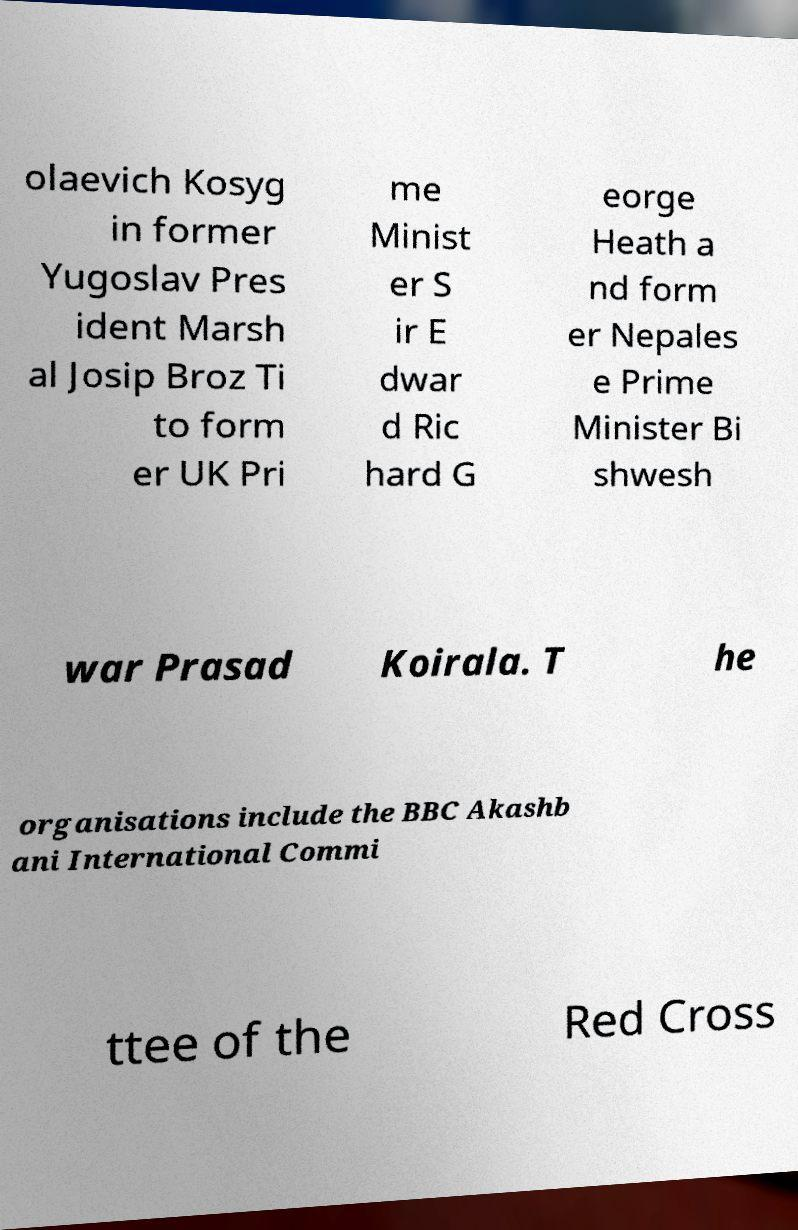For documentation purposes, I need the text within this image transcribed. Could you provide that? olaevich Kosyg in former Yugoslav Pres ident Marsh al Josip Broz Ti to form er UK Pri me Minist er S ir E dwar d Ric hard G eorge Heath a nd form er Nepales e Prime Minister Bi shwesh war Prasad Koirala. T he organisations include the BBC Akashb ani International Commi ttee of the Red Cross 